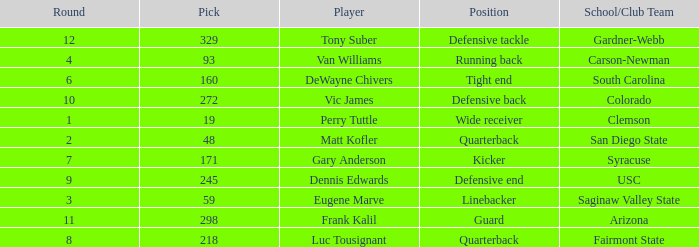Which player's pick is 160? DeWayne Chivers. 